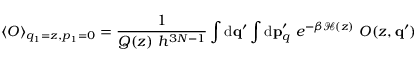<formula> <loc_0><loc_0><loc_500><loc_500>\left < O \right > _ { q _ { 1 } = z , p _ { 1 } = 0 } = \frac { 1 } { Q ( z ) \ h ^ { 3 N - 1 } } \int { d } { q } ^ { \prime } \int { d } { p } _ { q } ^ { \prime } \ e ^ { - \beta \mathcal { H } ( z ) } \ O ( z , { q } ^ { \prime } )</formula> 